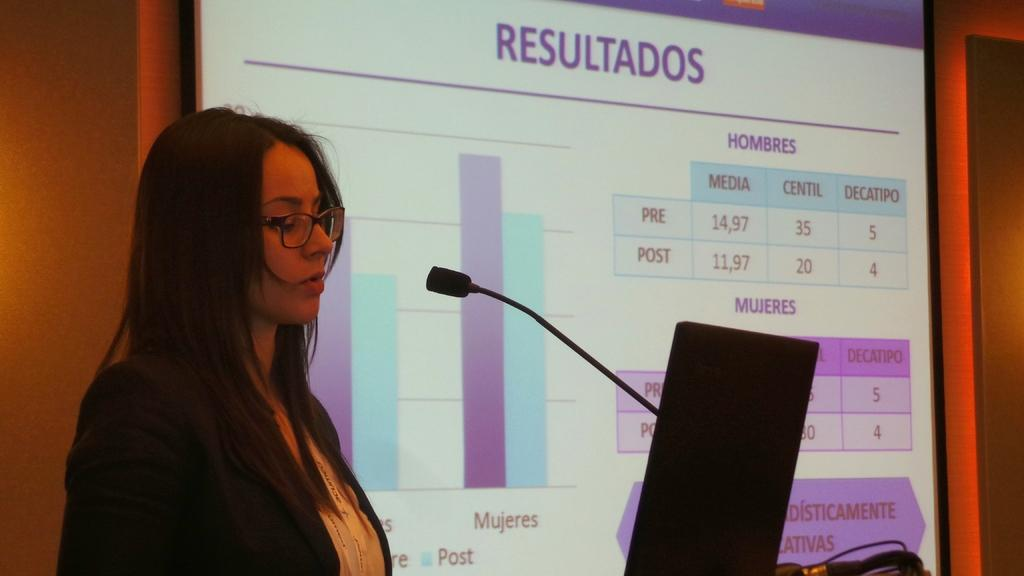Who is the main subject in the image? There is a woman in the image. What is the woman doing in the image? The woman is standing in front of a mic. What else can be seen in the image besides the woman? There is an object and a screen with text in the image. What is the background of the image? The background appears to be a wall. What type of apples are being harvested in the image? There are no apples or any indication of harvesting in the image. 